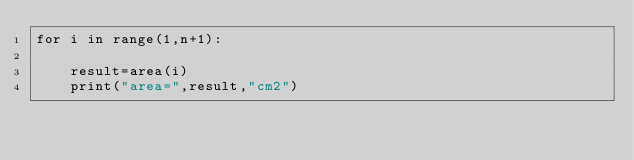Convert code to text. <code><loc_0><loc_0><loc_500><loc_500><_Python_>for i in range(1,n+1):
    
    result=area(i) 
    print("area=",result,"cm2") 
  </code> 